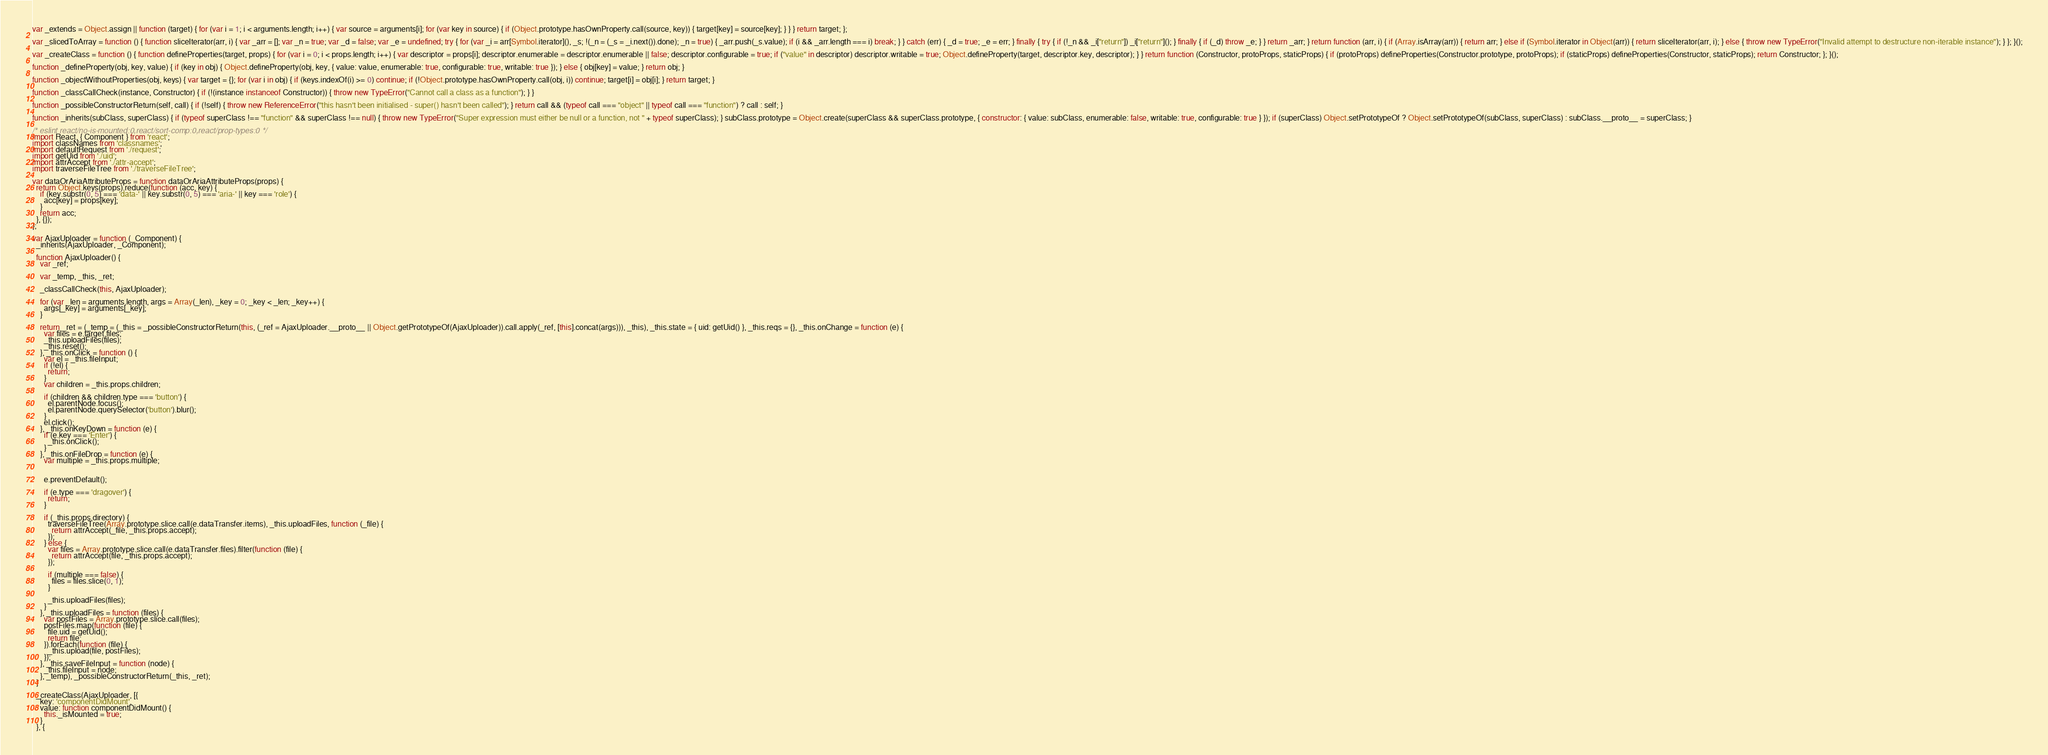<code> <loc_0><loc_0><loc_500><loc_500><_JavaScript_>var _extends = Object.assign || function (target) { for (var i = 1; i < arguments.length; i++) { var source = arguments[i]; for (var key in source) { if (Object.prototype.hasOwnProperty.call(source, key)) { target[key] = source[key]; } } } return target; };

var _slicedToArray = function () { function sliceIterator(arr, i) { var _arr = []; var _n = true; var _d = false; var _e = undefined; try { for (var _i = arr[Symbol.iterator](), _s; !(_n = (_s = _i.next()).done); _n = true) { _arr.push(_s.value); if (i && _arr.length === i) break; } } catch (err) { _d = true; _e = err; } finally { try { if (!_n && _i["return"]) _i["return"](); } finally { if (_d) throw _e; } } return _arr; } return function (arr, i) { if (Array.isArray(arr)) { return arr; } else if (Symbol.iterator in Object(arr)) { return sliceIterator(arr, i); } else { throw new TypeError("Invalid attempt to destructure non-iterable instance"); } }; }();

var _createClass = function () { function defineProperties(target, props) { for (var i = 0; i < props.length; i++) { var descriptor = props[i]; descriptor.enumerable = descriptor.enumerable || false; descriptor.configurable = true; if ("value" in descriptor) descriptor.writable = true; Object.defineProperty(target, descriptor.key, descriptor); } } return function (Constructor, protoProps, staticProps) { if (protoProps) defineProperties(Constructor.prototype, protoProps); if (staticProps) defineProperties(Constructor, staticProps); return Constructor; }; }();

function _defineProperty(obj, key, value) { if (key in obj) { Object.defineProperty(obj, key, { value: value, enumerable: true, configurable: true, writable: true }); } else { obj[key] = value; } return obj; }

function _objectWithoutProperties(obj, keys) { var target = {}; for (var i in obj) { if (keys.indexOf(i) >= 0) continue; if (!Object.prototype.hasOwnProperty.call(obj, i)) continue; target[i] = obj[i]; } return target; }

function _classCallCheck(instance, Constructor) { if (!(instance instanceof Constructor)) { throw new TypeError("Cannot call a class as a function"); } }

function _possibleConstructorReturn(self, call) { if (!self) { throw new ReferenceError("this hasn't been initialised - super() hasn't been called"); } return call && (typeof call === "object" || typeof call === "function") ? call : self; }

function _inherits(subClass, superClass) { if (typeof superClass !== "function" && superClass !== null) { throw new TypeError("Super expression must either be null or a function, not " + typeof superClass); } subClass.prototype = Object.create(superClass && superClass.prototype, { constructor: { value: subClass, enumerable: false, writable: true, configurable: true } }); if (superClass) Object.setPrototypeOf ? Object.setPrototypeOf(subClass, superClass) : subClass.__proto__ = superClass; }

/* eslint react/no-is-mounted:0,react/sort-comp:0,react/prop-types:0 */
import React, { Component } from 'react';
import classNames from 'classnames';
import defaultRequest from './request';
import getUid from './uid';
import attrAccept from './attr-accept';
import traverseFileTree from './traverseFileTree';

var dataOrAriaAttributeProps = function dataOrAriaAttributeProps(props) {
  return Object.keys(props).reduce(function (acc, key) {
    if (key.substr(0, 5) === 'data-' || key.substr(0, 5) === 'aria-' || key === 'role') {
      acc[key] = props[key];
    }
    return acc;
  }, {});
};

var AjaxUploader = function (_Component) {
  _inherits(AjaxUploader, _Component);

  function AjaxUploader() {
    var _ref;

    var _temp, _this, _ret;

    _classCallCheck(this, AjaxUploader);

    for (var _len = arguments.length, args = Array(_len), _key = 0; _key < _len; _key++) {
      args[_key] = arguments[_key];
    }

    return _ret = (_temp = (_this = _possibleConstructorReturn(this, (_ref = AjaxUploader.__proto__ || Object.getPrototypeOf(AjaxUploader)).call.apply(_ref, [this].concat(args))), _this), _this.state = { uid: getUid() }, _this.reqs = {}, _this.onChange = function (e) {
      var files = e.target.files;
      _this.uploadFiles(files);
      _this.reset();
    }, _this.onClick = function () {
      var el = _this.fileInput;
      if (!el) {
        return;
      }
      var children = _this.props.children;

      if (children && children.type === 'button') {
        el.parentNode.focus();
        el.parentNode.querySelector('button').blur();
      }
      el.click();
    }, _this.onKeyDown = function (e) {
      if (e.key === 'Enter') {
        _this.onClick();
      }
    }, _this.onFileDrop = function (e) {
      var multiple = _this.props.multiple;


      e.preventDefault();

      if (e.type === 'dragover') {
        return;
      }

      if (_this.props.directory) {
        traverseFileTree(Array.prototype.slice.call(e.dataTransfer.items), _this.uploadFiles, function (_file) {
          return attrAccept(_file, _this.props.accept);
        });
      } else {
        var files = Array.prototype.slice.call(e.dataTransfer.files).filter(function (file) {
          return attrAccept(file, _this.props.accept);
        });

        if (multiple === false) {
          files = files.slice(0, 1);
        }

        _this.uploadFiles(files);
      }
    }, _this.uploadFiles = function (files) {
      var postFiles = Array.prototype.slice.call(files);
      postFiles.map(function (file) {
        file.uid = getUid();
        return file;
      }).forEach(function (file) {
        _this.upload(file, postFiles);
      });
    }, _this.saveFileInput = function (node) {
      _this.fileInput = node;
    }, _temp), _possibleConstructorReturn(_this, _ret);
  }

  _createClass(AjaxUploader, [{
    key: 'componentDidMount',
    value: function componentDidMount() {
      this._isMounted = true;
    }
  }, {</code> 